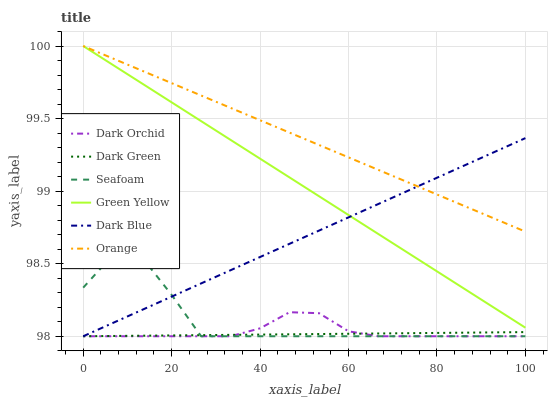Does Dark Orchid have the minimum area under the curve?
Answer yes or no. No. Does Dark Orchid have the maximum area under the curve?
Answer yes or no. No. Is Dark Orchid the smoothest?
Answer yes or no. No. Is Dark Orchid the roughest?
Answer yes or no. No. Does Orange have the lowest value?
Answer yes or no. No. Does Dark Orchid have the highest value?
Answer yes or no. No. Is Seafoam less than Green Yellow?
Answer yes or no. Yes. Is Green Yellow greater than Dark Orchid?
Answer yes or no. Yes. Does Seafoam intersect Green Yellow?
Answer yes or no. No. 